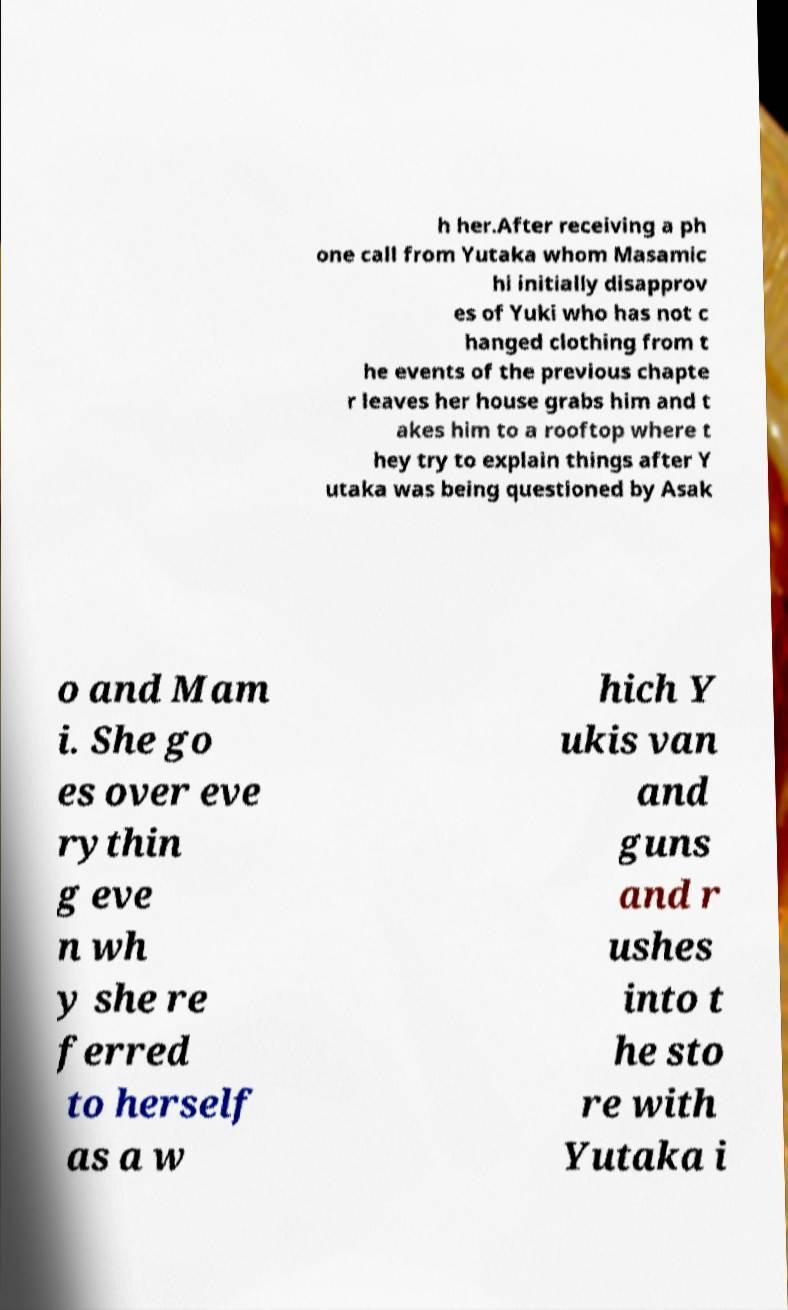Could you extract and type out the text from this image? h her.After receiving a ph one call from Yutaka whom Masamic hi initially disapprov es of Yuki who has not c hanged clothing from t he events of the previous chapte r leaves her house grabs him and t akes him to a rooftop where t hey try to explain things after Y utaka was being questioned by Asak o and Mam i. She go es over eve rythin g eve n wh y she re ferred to herself as a w hich Y ukis van and guns and r ushes into t he sto re with Yutaka i 